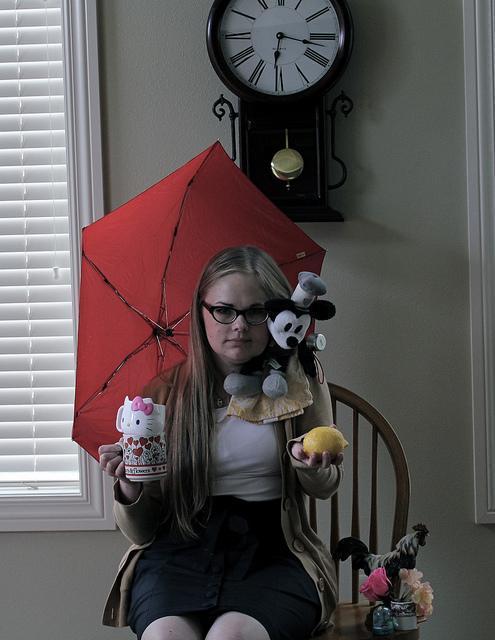Is the caption "The umbrella is touching the orange." a true representation of the image?
Answer yes or no. No. 